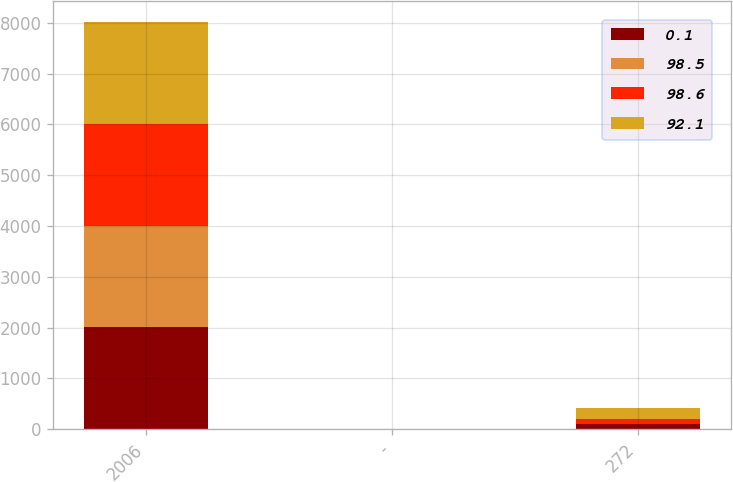<chart> <loc_0><loc_0><loc_500><loc_500><stacked_bar_chart><ecel><fcel>2006<fcel>-<fcel>272<nl><fcel>0.1<fcel>2005<fcel>1.5<fcel>98.5<nl><fcel>98.5<fcel>2005<fcel>0.1<fcel>0.1<nl><fcel>98.6<fcel>2005<fcel>1.6<fcel>98.6<nl><fcel>92.1<fcel>2004<fcel>6.9<fcel>227.1<nl></chart> 